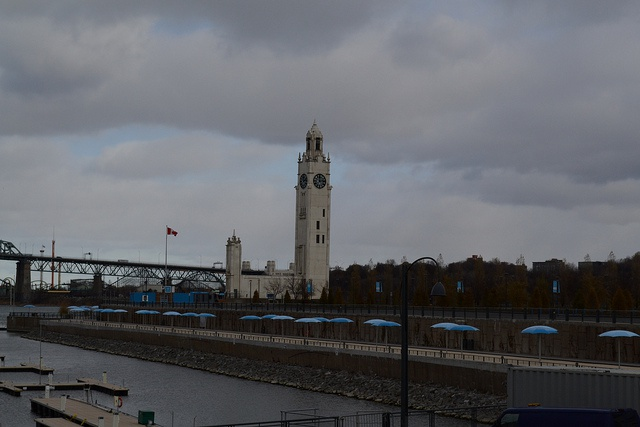Describe the objects in this image and their specific colors. I can see umbrella in gray, black, and blue tones, umbrella in gray and black tones, umbrella in gray, black, and blue tones, umbrella in gray, black, and blue tones, and umbrella in gray, black, and blue tones in this image. 